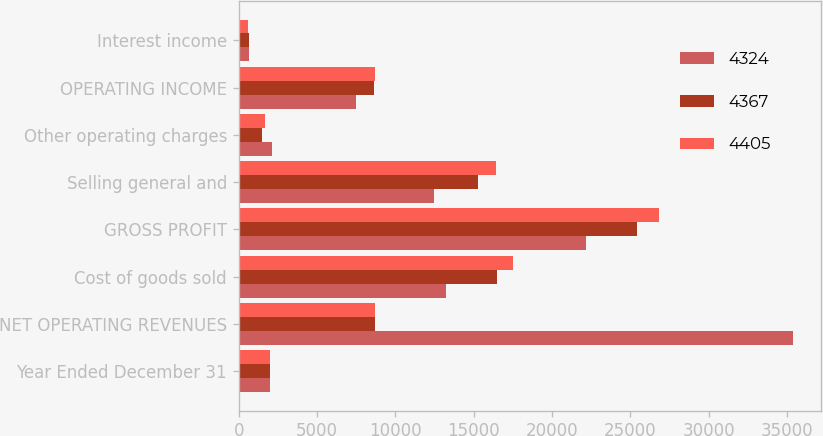Convert chart to OTSL. <chart><loc_0><loc_0><loc_500><loc_500><stacked_bar_chart><ecel><fcel>Year Ended December 31<fcel>NET OPERATING REVENUES<fcel>Cost of goods sold<fcel>GROSS PROFIT<fcel>Selling general and<fcel>Other operating charges<fcel>OPERATING INCOME<fcel>Interest income<nl><fcel>4324<fcel>2017<fcel>35410<fcel>13256<fcel>22154<fcel>12496<fcel>2157<fcel>7501<fcel>677<nl><fcel>4367<fcel>2016<fcel>8677<fcel>16465<fcel>25398<fcel>15262<fcel>1510<fcel>8626<fcel>642<nl><fcel>4405<fcel>2015<fcel>8677<fcel>17482<fcel>26812<fcel>16427<fcel>1657<fcel>8728<fcel>613<nl></chart> 